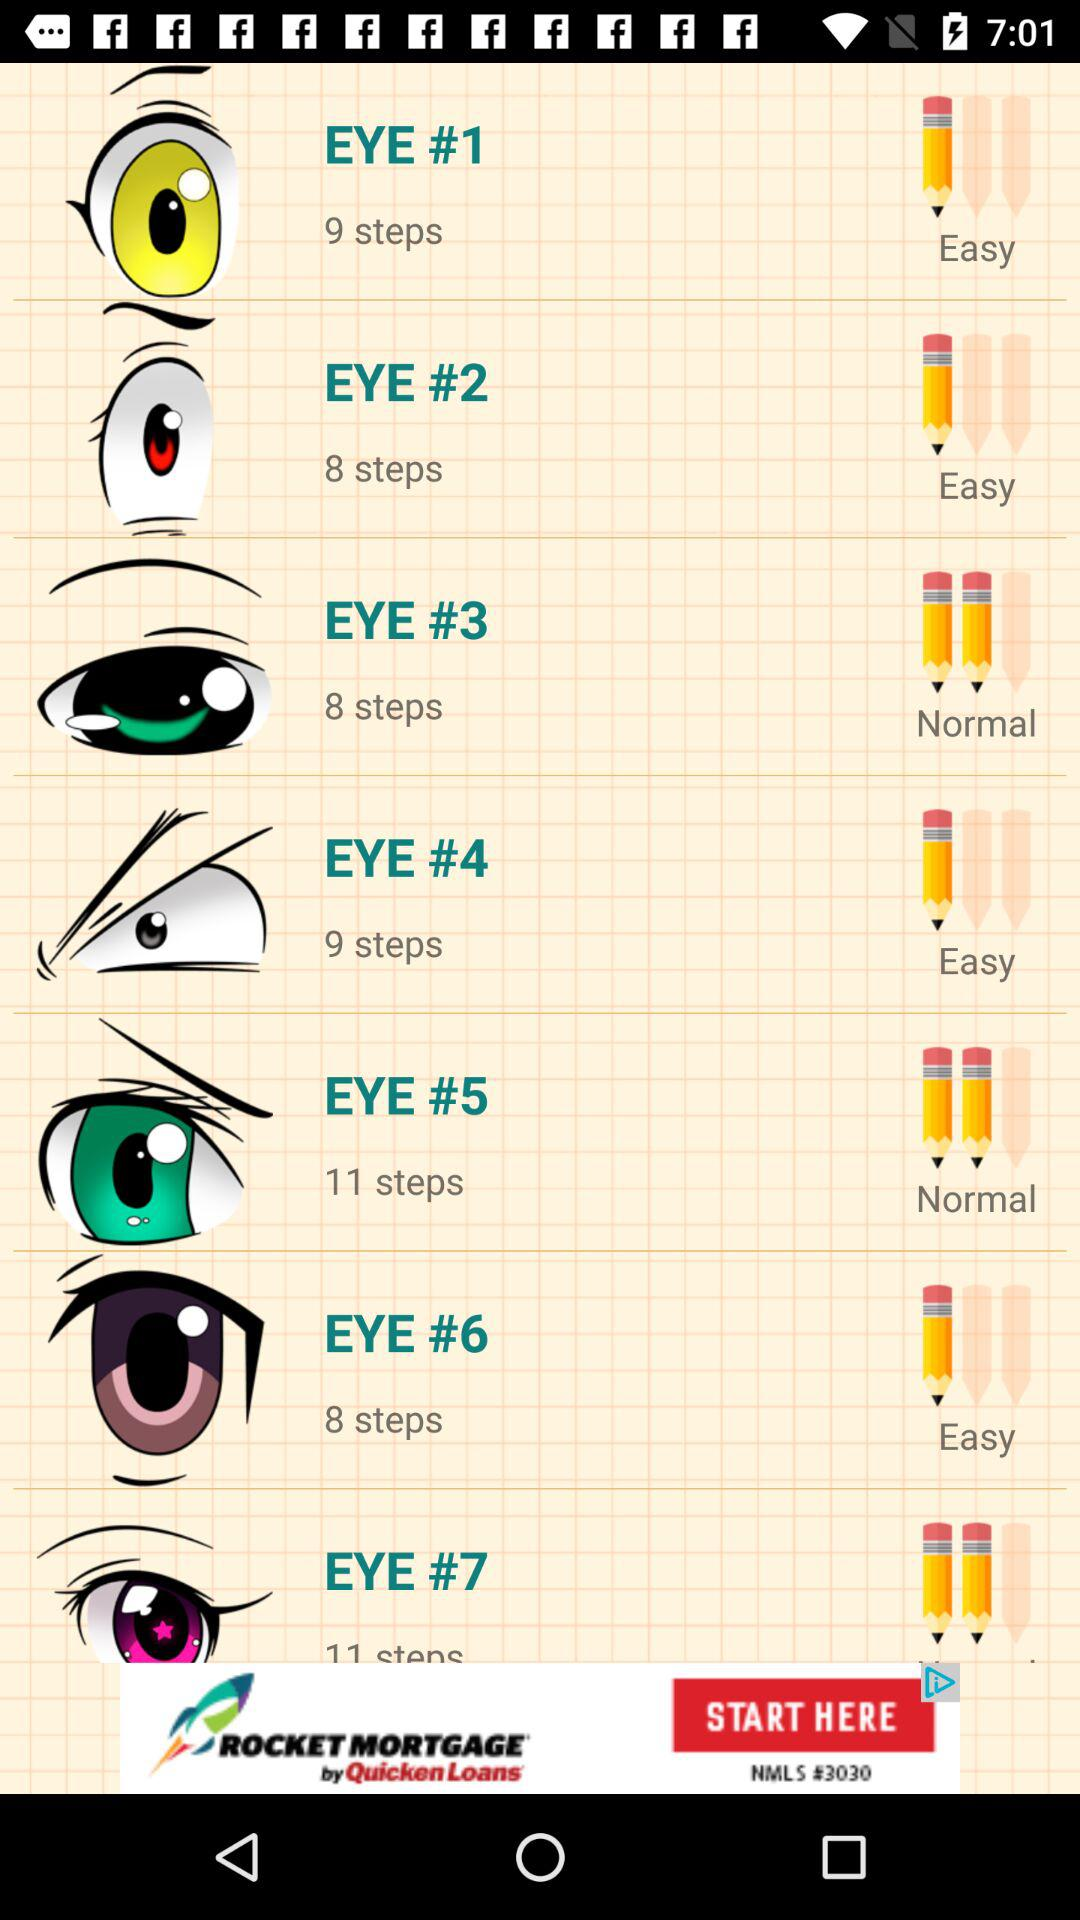How many steps are there in "EYE #2"? There are 8 steps. 